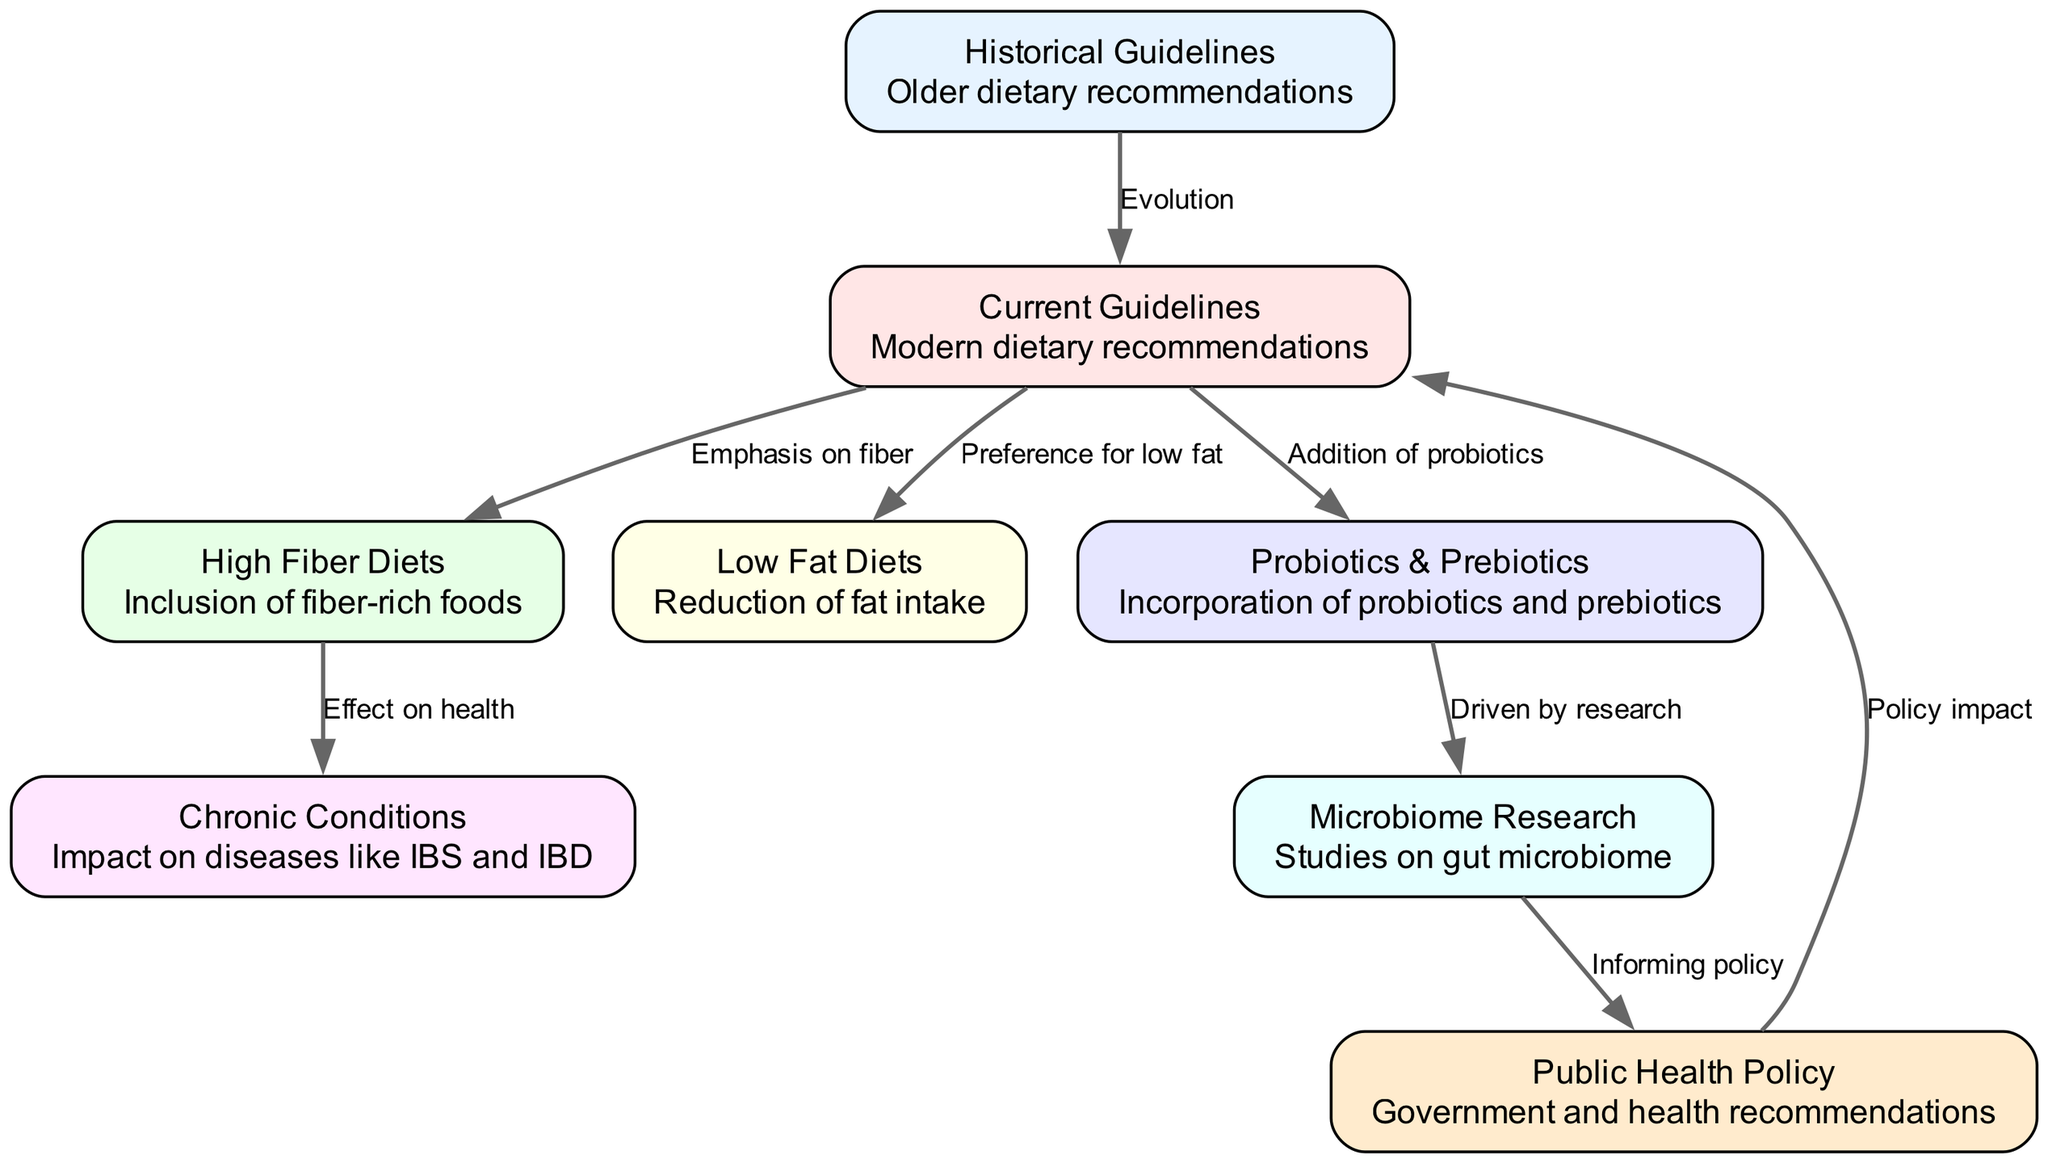What are the two main categories of guidelines in the diagram? The diagram shows two main categories of guidelines: "Historical Guidelines" and "Current Guidelines", represented as nodes in the diagram.
Answer: Historical Guidelines, Current Guidelines How many edges connect to the "Current Guidelines" node? The "Current Guidelines" node has three edges connected to it, indicating the emphasis on high fiber diets, low fat diets, and probiotics & prebiotics, respectively.
Answer: 3 What is the effect of high fiber diets according to the diagram? The diagram indicates that "High Fiber Diets" have an "Effect on health", specifically linking to "Chronic Conditions", which suggests a positive impact on digestive health.
Answer: Effect on health Which recommendation is directly influenced by public health policy? According to the diagram, "Current Guidelines" are directly influenced by "Public Health Policy", indicating that current recommendations are shaped by governmental and health authorities.
Answer: Current Guidelines How does microbiome research influence public health policy? The diagram shows that "Microbiome Research" informs "Public Health Policy", highlighting the role of scientific studies in shaping dietary recommendations at a policy level.
Answer: Informing policy What type of dietary recommendation is emphasized in current guidelines? The current guidelines emphasize a "high fiber diet", as indicated by the direct edge from "Current Guidelines" to "High Fiber Diets".
Answer: High Fiber Diets What category impacts chronic conditions in the diagram? "High Fiber Diets" are shown to impact "Chronic Conditions" in the diagram, establishing a connection between dietary intake and digestive health outcomes.
Answer: Chronic Conditions What research drives the incorporation of probiotics and prebiotics? The incorporation of "Probiotics & Prebiotics" is driven by "Microbiome Research" according to the diagram, indicating a strong link between scientific findings and dietary trends.
Answer: Microbiome Research What is the evolution between the historical and current guidelines? The diagram illustrates the evolution from "Historical Guidelines" to "Current Guidelines" as a process of adaptation and change in dietary recommendations over time.
Answer: Evolution 